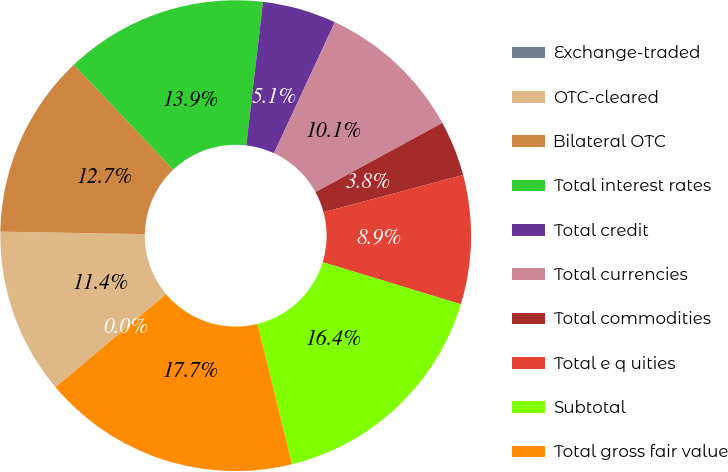<chart> <loc_0><loc_0><loc_500><loc_500><pie_chart><fcel>Exchange-traded<fcel>OTC-cleared<fcel>Bilateral OTC<fcel>Total interest rates<fcel>Total credit<fcel>Total currencies<fcel>Total commodities<fcel>Total e q uities<fcel>Subtotal<fcel>Total gross fair value<nl><fcel>0.01%<fcel>11.39%<fcel>12.66%<fcel>13.92%<fcel>5.07%<fcel>10.13%<fcel>3.8%<fcel>8.86%<fcel>16.45%<fcel>17.72%<nl></chart> 